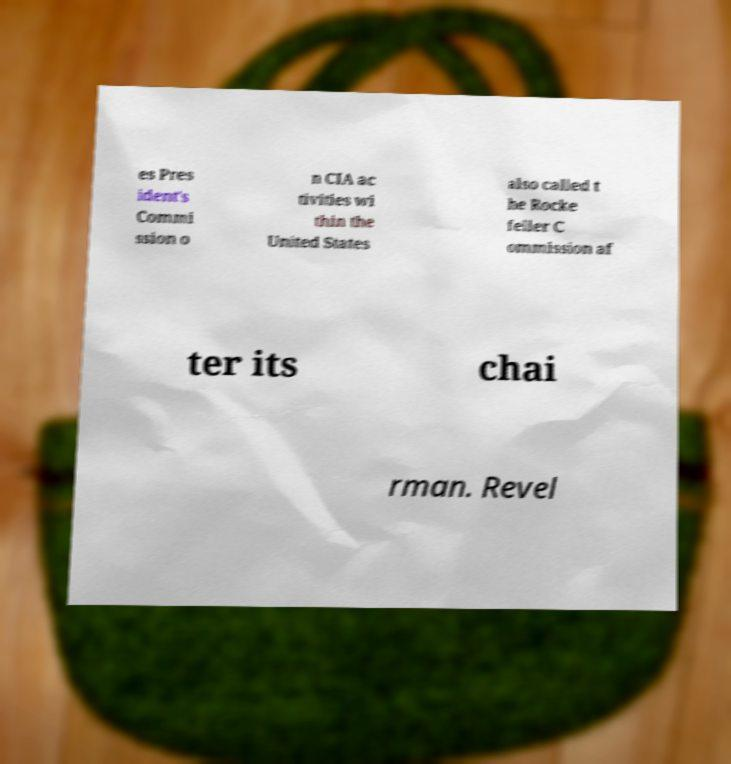I need the written content from this picture converted into text. Can you do that? es Pres ident's Commi ssion o n CIA ac tivities wi thin the United States also called t he Rocke feller C ommission af ter its chai rman. Revel 